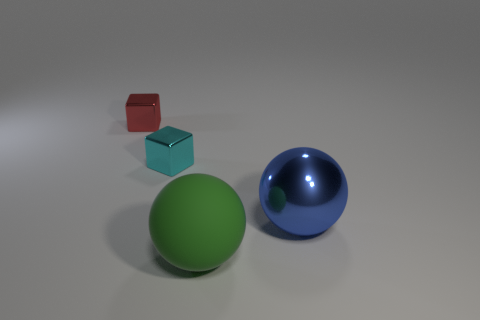The object that is the same size as the green matte sphere is what color?
Provide a succinct answer. Blue. What number of cyan cubes are there?
Offer a very short reply. 1. Do the big thing that is to the right of the green rubber object and the large green ball have the same material?
Give a very brief answer. No. What is the material of the thing that is to the right of the red block and behind the big blue metallic ball?
Your answer should be compact. Metal. There is a big green sphere that is right of the metal block in front of the small red object; what is its material?
Provide a succinct answer. Rubber. There is a object that is to the right of the sphere that is left of the large ball that is behind the green thing; how big is it?
Ensure brevity in your answer.  Large. How many cyan things are made of the same material as the blue object?
Ensure brevity in your answer.  1. What is the color of the small block that is in front of the tiny thing that is left of the cyan metallic thing?
Give a very brief answer. Cyan. How many objects are either large blue metal balls or large balls behind the large green thing?
Your answer should be compact. 1. How many yellow things are either tiny metallic objects or matte balls?
Give a very brief answer. 0. 